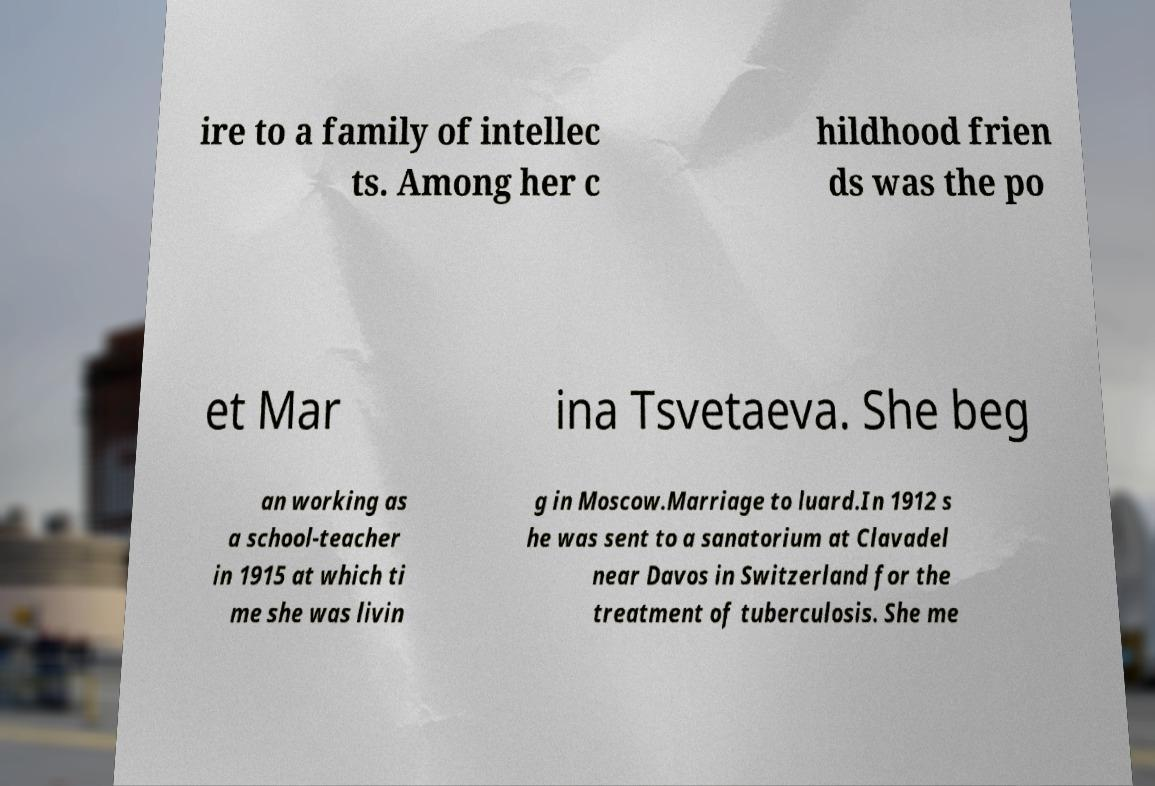What messages or text are displayed in this image? I need them in a readable, typed format. ire to a family of intellec ts. Among her c hildhood frien ds was the po et Mar ina Tsvetaeva. She beg an working as a school-teacher in 1915 at which ti me she was livin g in Moscow.Marriage to luard.In 1912 s he was sent to a sanatorium at Clavadel near Davos in Switzerland for the treatment of tuberculosis. She me 